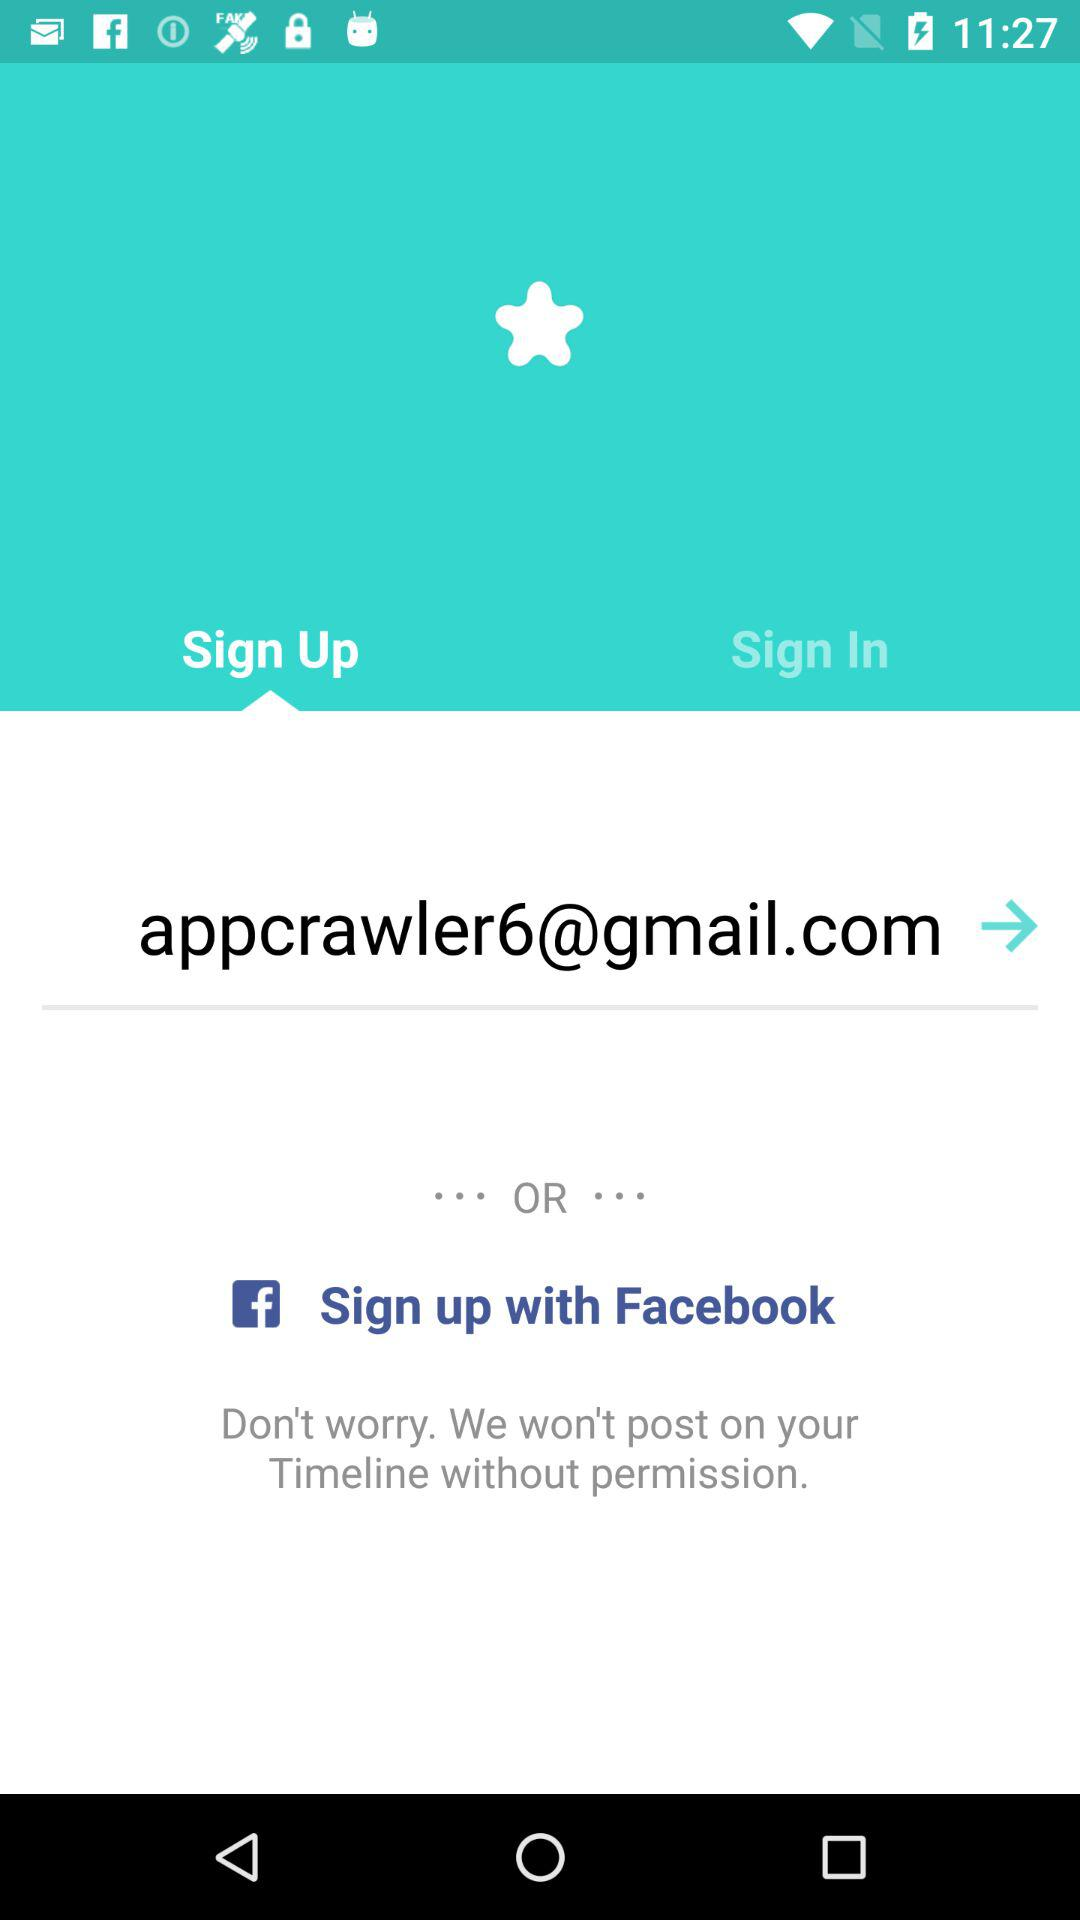What is the other option to sign up? The other option to sign up is "Facebook". 